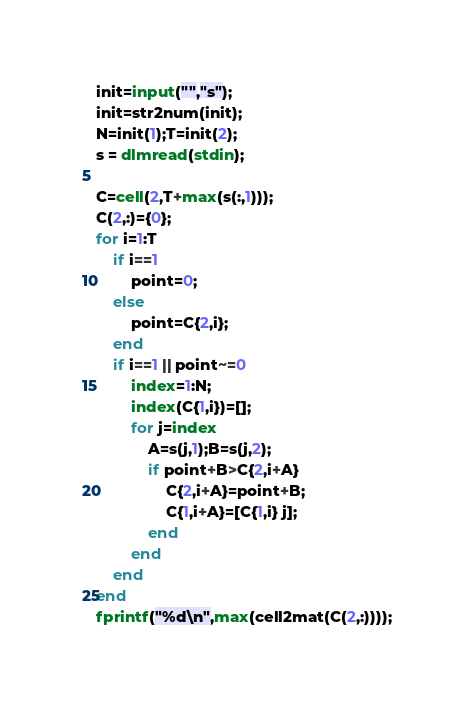Convert code to text. <code><loc_0><loc_0><loc_500><loc_500><_Octave_>init=input("","s");
init=str2num(init);
N=init(1);T=init(2);
s = dlmread(stdin);

C=cell(2,T+max(s(:,1)));
C(2,:)={0};
for i=1:T
    if i==1
        point=0;
    else
        point=C{2,i};
    end
    if i==1 || point~=0
        index=1:N;
        index(C{1,i})=[];
        for j=index
            A=s(j,1);B=s(j,2);
            if point+B>C{2,i+A}
                C{2,i+A}=point+B;
                C{1,i+A}=[C{1,i} j];
            end
        end
    end    
end
fprintf("%d\n",max(cell2mat(C(2,:))));
</code> 